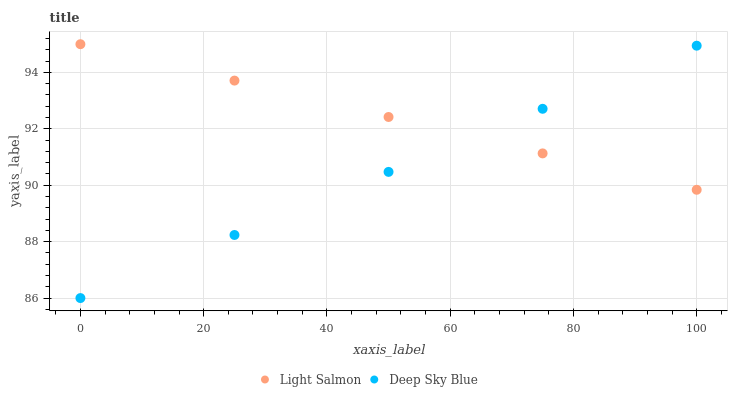Does Deep Sky Blue have the minimum area under the curve?
Answer yes or no. Yes. Does Light Salmon have the maximum area under the curve?
Answer yes or no. Yes. Does Deep Sky Blue have the maximum area under the curve?
Answer yes or no. No. Is Deep Sky Blue the smoothest?
Answer yes or no. Yes. Is Light Salmon the roughest?
Answer yes or no. Yes. Is Deep Sky Blue the roughest?
Answer yes or no. No. Does Deep Sky Blue have the lowest value?
Answer yes or no. Yes. Does Light Salmon have the highest value?
Answer yes or no. Yes. Does Deep Sky Blue have the highest value?
Answer yes or no. No. Does Light Salmon intersect Deep Sky Blue?
Answer yes or no. Yes. Is Light Salmon less than Deep Sky Blue?
Answer yes or no. No. Is Light Salmon greater than Deep Sky Blue?
Answer yes or no. No. 